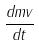Convert formula to latex. <formula><loc_0><loc_0><loc_500><loc_500>\frac { d m v } { d t }</formula> 